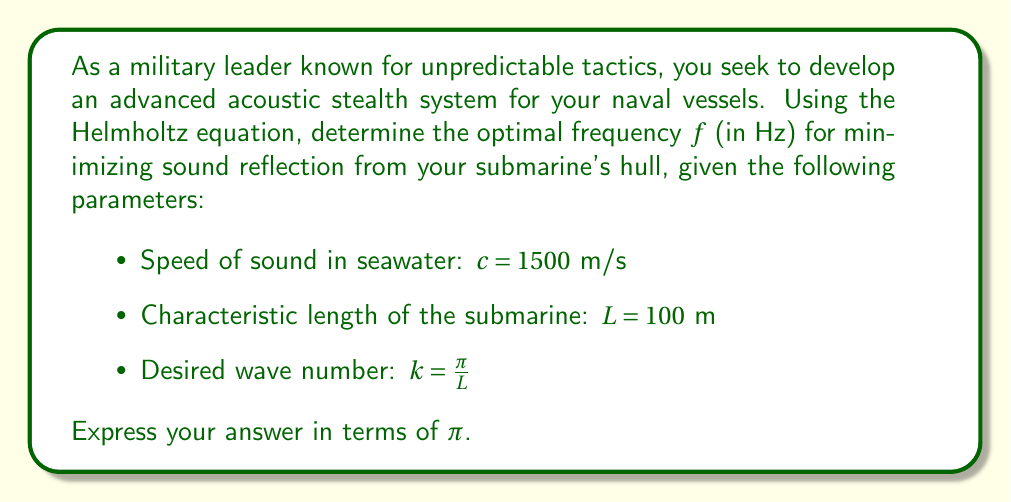Show me your answer to this math problem. To solve this problem, we'll use the Helmholtz equation and the relationship between frequency, wave number, and the speed of sound.

1) The Helmholtz equation is given by:

   $$\nabla^2 u + k^2 u = 0$$

   where $k$ is the wave number.

2) We're given that $k = \frac{\pi}{L}$, where $L$ is the characteristic length of the submarine.

3) The relationship between wave number $k$, frequency $f$, and speed of sound $c$ is:

   $$k = \frac{2\pi f}{c}$$

4) We can equate these two expressions for $k$:

   $$\frac{\pi}{L} = \frac{2\pi f}{c}$$

5) Solving for $f$:

   $$f = \frac{c}{2L}$$

6) Now we can substitute the given values:

   $$f = \frac{1500 \text{ m/s}}{2 \cdot 100 \text{ m}}$$

7) Simplifying:

   $$f = \frac{1500}{200} = 7.5 \text{ Hz}$$

8) To express this in terms of $\pi$, we can use the fact that $\pi \approx 3.14159$:

   $$f = \frac{15}{2\pi} \pi \approx 7.5 \pi \text{ Hz}$$

Therefore, the optimal frequency for minimizing sound reflection is approximately $\frac{15}{2\pi} \pi$ Hz or $7.5 \pi$ Hz.
Answer: $f = \frac{15}{2\pi} \pi \text{ Hz}$ or approximately $7.5 \pi \text{ Hz}$ 